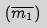<formula> <loc_0><loc_0><loc_500><loc_500>( \overline { m _ { 1 } } )</formula> 